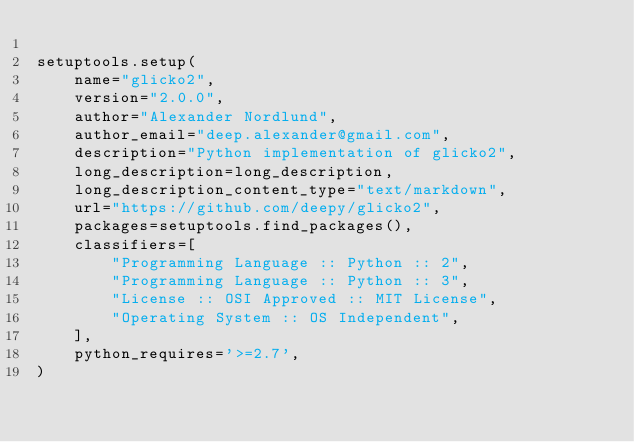Convert code to text. <code><loc_0><loc_0><loc_500><loc_500><_Python_>
setuptools.setup(
    name="glicko2",
    version="2.0.0",
    author="Alexander Nordlund",
    author_email="deep.alexander@gmail.com",
    description="Python implementation of glicko2",
    long_description=long_description,
    long_description_content_type="text/markdown",
    url="https://github.com/deepy/glicko2",
    packages=setuptools.find_packages(),
    classifiers=[
        "Programming Language :: Python :: 2",
        "Programming Language :: Python :: 3",
        "License :: OSI Approved :: MIT License",
        "Operating System :: OS Independent",
    ],
    python_requires='>=2.7',
)</code> 